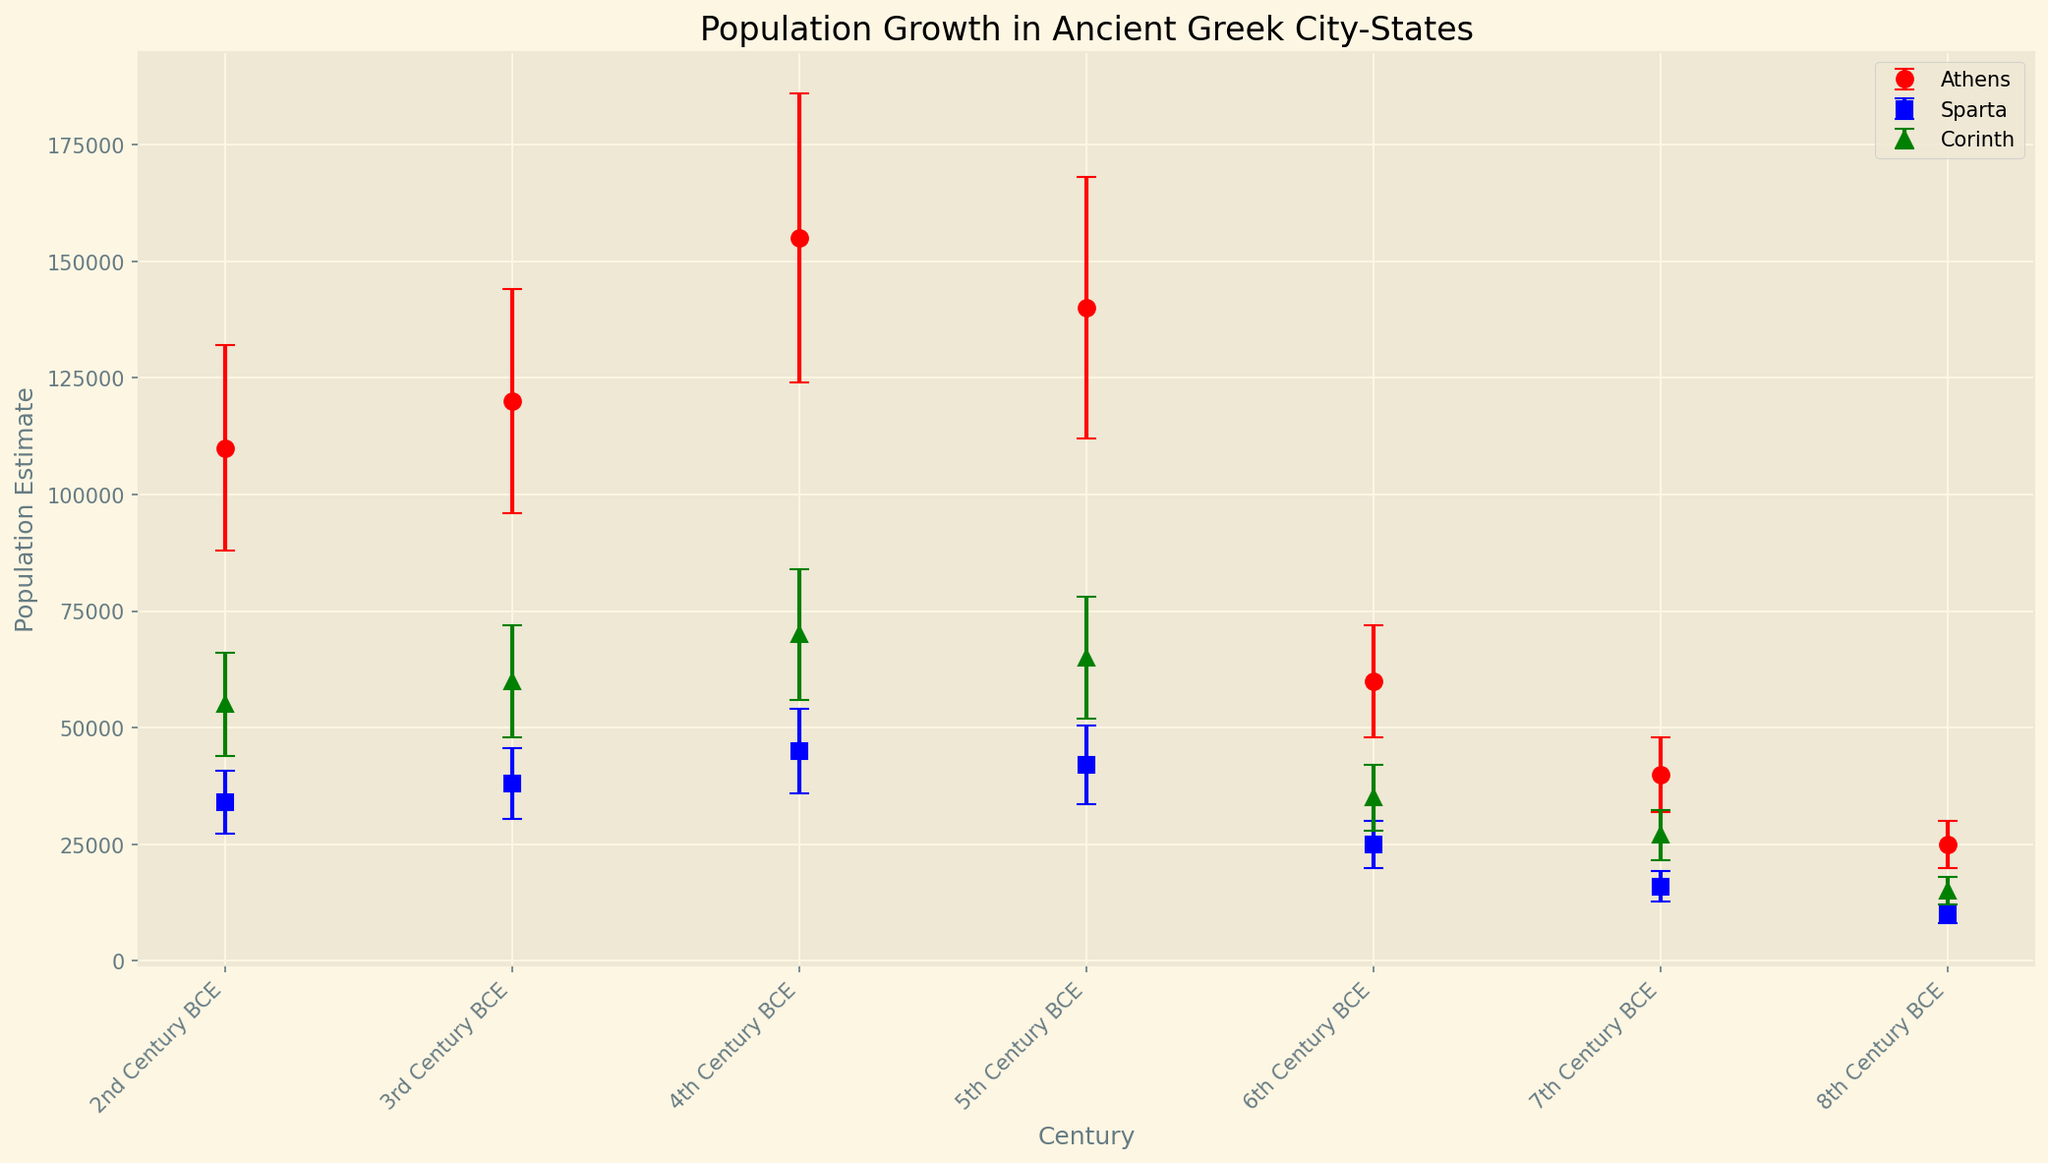Which city-state had the highest population estimate in the 5th Century BCE? The highest point on the y-axis (population estimate) for the 5th Century BCE is Athens, indicated by the red marker, which is at 140000.
Answer: Athens Which city-state experienced the largest population growth from the 8th to the 4th Century BCE? Athens grew from 25000 in the 8th Century BCE to 155000 in the 4th Century BCE, a total increase of 130000. This is larger compared to Sparta's increase of 35000 and Corinth's increase of 55000.
Answer: Athens What is the difference in population estimates between Athens and Sparta in the 6th Century BCE? In the 6th Century BCE, Athens had a population estimate of 60000 while Sparta had 25000. The difference is 60000 - 25000 = 35000.
Answer: 35000 Which city-state had the most notable fluctuation in its population estimates across the centuries? Athens shows significant increases and decreases in population estimates, growing rapidly then dropping in the 3rd and 2nd Centuries BCE, as indicated by the steep lines and error bars.
Answer: Athens How do the error ranges for Corinth compare in the 4th and 3rd Centuries BCE? The error range for Corinth in the 4th Century BCE is 14000, while in the 3rd Century BCE it is 12000. The 4th Century BCE has a larger error range by 2000.
Answer: The 4th Century is larger Between the 7th and 5th Century BCE, which city-state had the most consistent (least fluctuating) population growth? Sparta had a consistent growth from 10000 to 42000 across the centuries, as shown by the less steep and evenly distributed error bars compared to the other city-states.
Answer: Sparta What is the average population estimate of Corinth from the 8th to the 2nd Century BCE? Average = (15000 + 27000 + 35000 + 65000 + 70000 + 60000 + 55000) / 7 = 75428.6.
Answer: 75428.6 Which city-state shows a population decrease between the 4th and 3rd Century BCE? Athens is the only city-state decreasing from 155000 in the 4th Century BCE to 120000 in the 3rd Century BCE, represented by the downward movement of the red markers.
Answer: Athens What is the visual pattern of population change in Sparta from the 8th to the 2nd Century BCE? Sparta's population estimates steadily increase but at a slower rate compared to Athens and Corinth, visually indicated by the steady upward slope of the blue markers.
Answer: Steady increase 